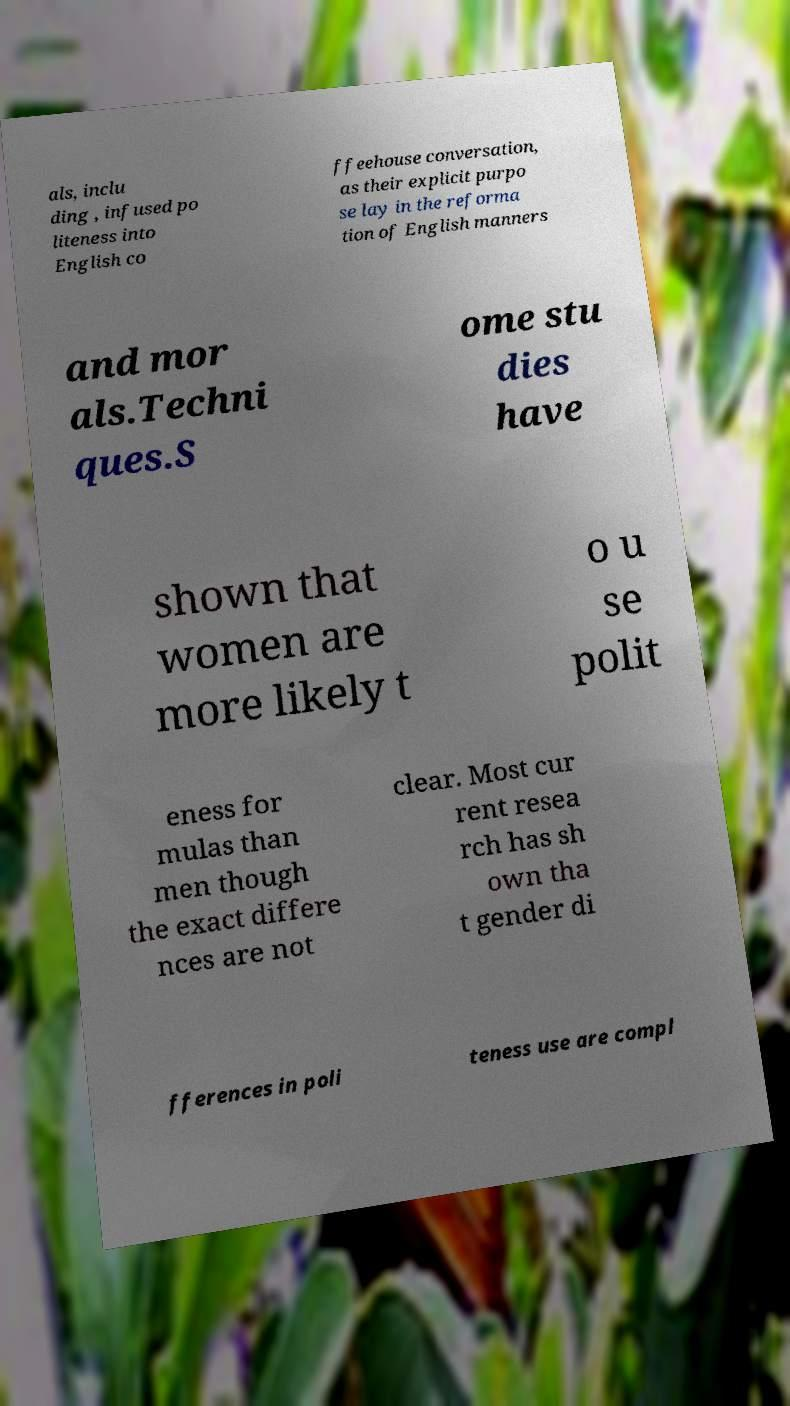What messages or text are displayed in this image? I need them in a readable, typed format. als, inclu ding , infused po liteness into English co ffeehouse conversation, as their explicit purpo se lay in the reforma tion of English manners and mor als.Techni ques.S ome stu dies have shown that women are more likely t o u se polit eness for mulas than men though the exact differe nces are not clear. Most cur rent resea rch has sh own tha t gender di fferences in poli teness use are compl 